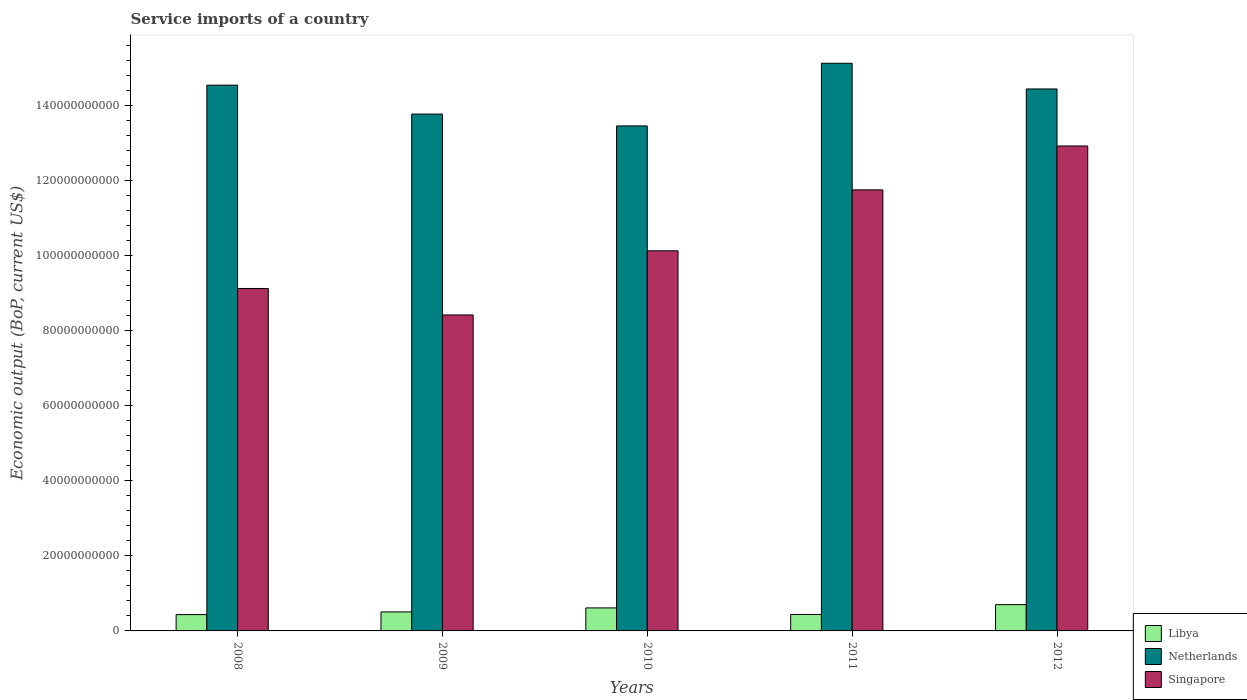Are the number of bars on each tick of the X-axis equal?
Offer a very short reply. Yes. How many bars are there on the 4th tick from the left?
Give a very brief answer. 3. How many bars are there on the 1st tick from the right?
Your answer should be very brief. 3. What is the service imports in Libya in 2010?
Ensure brevity in your answer.  6.13e+09. Across all years, what is the maximum service imports in Libya?
Ensure brevity in your answer.  7.00e+09. Across all years, what is the minimum service imports in Libya?
Ensure brevity in your answer.  4.34e+09. What is the total service imports in Libya in the graph?
Make the answer very short. 2.69e+1. What is the difference between the service imports in Singapore in 2008 and that in 2012?
Make the answer very short. -3.79e+1. What is the difference between the service imports in Netherlands in 2008 and the service imports in Libya in 2012?
Offer a terse response. 1.38e+11. What is the average service imports in Netherlands per year?
Provide a short and direct response. 1.43e+11. In the year 2010, what is the difference between the service imports in Netherlands and service imports in Libya?
Make the answer very short. 1.28e+11. In how many years, is the service imports in Netherlands greater than 48000000000 US$?
Your answer should be very brief. 5. What is the ratio of the service imports in Libya in 2008 to that in 2012?
Provide a succinct answer. 0.62. Is the service imports in Netherlands in 2011 less than that in 2012?
Give a very brief answer. No. What is the difference between the highest and the second highest service imports in Netherlands?
Your answer should be compact. 5.83e+09. What is the difference between the highest and the lowest service imports in Libya?
Your response must be concise. 2.65e+09. Is the sum of the service imports in Singapore in 2011 and 2012 greater than the maximum service imports in Netherlands across all years?
Offer a terse response. Yes. What does the 2nd bar from the left in 2012 represents?
Keep it short and to the point. Netherlands. What does the 1st bar from the right in 2008 represents?
Your answer should be compact. Singapore. Are all the bars in the graph horizontal?
Your answer should be very brief. No. How many years are there in the graph?
Your response must be concise. 5. How many legend labels are there?
Offer a terse response. 3. How are the legend labels stacked?
Provide a short and direct response. Vertical. What is the title of the graph?
Give a very brief answer. Service imports of a country. Does "Lebanon" appear as one of the legend labels in the graph?
Offer a terse response. No. What is the label or title of the X-axis?
Provide a succinct answer. Years. What is the label or title of the Y-axis?
Your answer should be very brief. Economic output (BoP, current US$). What is the Economic output (BoP, current US$) of Libya in 2008?
Offer a terse response. 4.34e+09. What is the Economic output (BoP, current US$) in Netherlands in 2008?
Offer a very short reply. 1.45e+11. What is the Economic output (BoP, current US$) of Singapore in 2008?
Offer a very short reply. 9.12e+1. What is the Economic output (BoP, current US$) in Libya in 2009?
Offer a very short reply. 5.06e+09. What is the Economic output (BoP, current US$) of Netherlands in 2009?
Provide a succinct answer. 1.38e+11. What is the Economic output (BoP, current US$) of Singapore in 2009?
Make the answer very short. 8.41e+1. What is the Economic output (BoP, current US$) of Libya in 2010?
Make the answer very short. 6.13e+09. What is the Economic output (BoP, current US$) in Netherlands in 2010?
Offer a very short reply. 1.34e+11. What is the Economic output (BoP, current US$) in Singapore in 2010?
Make the answer very short. 1.01e+11. What is the Economic output (BoP, current US$) in Libya in 2011?
Provide a short and direct response. 4.39e+09. What is the Economic output (BoP, current US$) in Netherlands in 2011?
Ensure brevity in your answer.  1.51e+11. What is the Economic output (BoP, current US$) in Singapore in 2011?
Provide a short and direct response. 1.17e+11. What is the Economic output (BoP, current US$) in Libya in 2012?
Your answer should be compact. 7.00e+09. What is the Economic output (BoP, current US$) in Netherlands in 2012?
Give a very brief answer. 1.44e+11. What is the Economic output (BoP, current US$) in Singapore in 2012?
Make the answer very short. 1.29e+11. Across all years, what is the maximum Economic output (BoP, current US$) of Libya?
Provide a short and direct response. 7.00e+09. Across all years, what is the maximum Economic output (BoP, current US$) of Netherlands?
Give a very brief answer. 1.51e+11. Across all years, what is the maximum Economic output (BoP, current US$) of Singapore?
Offer a terse response. 1.29e+11. Across all years, what is the minimum Economic output (BoP, current US$) of Libya?
Offer a terse response. 4.34e+09. Across all years, what is the minimum Economic output (BoP, current US$) of Netherlands?
Your answer should be compact. 1.34e+11. Across all years, what is the minimum Economic output (BoP, current US$) in Singapore?
Offer a very short reply. 8.41e+1. What is the total Economic output (BoP, current US$) in Libya in the graph?
Keep it short and to the point. 2.69e+1. What is the total Economic output (BoP, current US$) of Netherlands in the graph?
Make the answer very short. 7.13e+11. What is the total Economic output (BoP, current US$) in Singapore in the graph?
Provide a short and direct response. 5.23e+11. What is the difference between the Economic output (BoP, current US$) of Libya in 2008 and that in 2009?
Ensure brevity in your answer.  -7.19e+08. What is the difference between the Economic output (BoP, current US$) in Netherlands in 2008 and that in 2009?
Your response must be concise. 7.70e+09. What is the difference between the Economic output (BoP, current US$) in Singapore in 2008 and that in 2009?
Keep it short and to the point. 7.05e+09. What is the difference between the Economic output (BoP, current US$) in Libya in 2008 and that in 2010?
Keep it short and to the point. -1.78e+09. What is the difference between the Economic output (BoP, current US$) of Netherlands in 2008 and that in 2010?
Provide a short and direct response. 1.09e+1. What is the difference between the Economic output (BoP, current US$) in Singapore in 2008 and that in 2010?
Offer a very short reply. -1.00e+1. What is the difference between the Economic output (BoP, current US$) in Libya in 2008 and that in 2011?
Your response must be concise. -4.22e+07. What is the difference between the Economic output (BoP, current US$) in Netherlands in 2008 and that in 2011?
Give a very brief answer. -5.83e+09. What is the difference between the Economic output (BoP, current US$) of Singapore in 2008 and that in 2011?
Offer a very short reply. -2.63e+1. What is the difference between the Economic output (BoP, current US$) in Libya in 2008 and that in 2012?
Keep it short and to the point. -2.65e+09. What is the difference between the Economic output (BoP, current US$) of Netherlands in 2008 and that in 2012?
Give a very brief answer. 1.01e+09. What is the difference between the Economic output (BoP, current US$) in Singapore in 2008 and that in 2012?
Give a very brief answer. -3.79e+1. What is the difference between the Economic output (BoP, current US$) of Libya in 2009 and that in 2010?
Provide a succinct answer. -1.06e+09. What is the difference between the Economic output (BoP, current US$) in Netherlands in 2009 and that in 2010?
Provide a short and direct response. 3.15e+09. What is the difference between the Economic output (BoP, current US$) in Singapore in 2009 and that in 2010?
Make the answer very short. -1.71e+1. What is the difference between the Economic output (BoP, current US$) of Libya in 2009 and that in 2011?
Your response must be concise. 6.77e+08. What is the difference between the Economic output (BoP, current US$) of Netherlands in 2009 and that in 2011?
Provide a succinct answer. -1.35e+1. What is the difference between the Economic output (BoP, current US$) in Singapore in 2009 and that in 2011?
Your answer should be compact. -3.33e+1. What is the difference between the Economic output (BoP, current US$) of Libya in 2009 and that in 2012?
Offer a very short reply. -1.93e+09. What is the difference between the Economic output (BoP, current US$) in Netherlands in 2009 and that in 2012?
Your response must be concise. -6.69e+09. What is the difference between the Economic output (BoP, current US$) in Singapore in 2009 and that in 2012?
Your answer should be very brief. -4.50e+1. What is the difference between the Economic output (BoP, current US$) of Libya in 2010 and that in 2011?
Offer a terse response. 1.74e+09. What is the difference between the Economic output (BoP, current US$) in Netherlands in 2010 and that in 2011?
Your answer should be very brief. -1.67e+1. What is the difference between the Economic output (BoP, current US$) in Singapore in 2010 and that in 2011?
Provide a succinct answer. -1.62e+1. What is the difference between the Economic output (BoP, current US$) of Libya in 2010 and that in 2012?
Ensure brevity in your answer.  -8.68e+08. What is the difference between the Economic output (BoP, current US$) of Netherlands in 2010 and that in 2012?
Offer a very short reply. -9.84e+09. What is the difference between the Economic output (BoP, current US$) of Singapore in 2010 and that in 2012?
Provide a short and direct response. -2.79e+1. What is the difference between the Economic output (BoP, current US$) in Libya in 2011 and that in 2012?
Keep it short and to the point. -2.61e+09. What is the difference between the Economic output (BoP, current US$) of Netherlands in 2011 and that in 2012?
Offer a very short reply. 6.84e+09. What is the difference between the Economic output (BoP, current US$) of Singapore in 2011 and that in 2012?
Keep it short and to the point. -1.17e+1. What is the difference between the Economic output (BoP, current US$) of Libya in 2008 and the Economic output (BoP, current US$) of Netherlands in 2009?
Offer a terse response. -1.33e+11. What is the difference between the Economic output (BoP, current US$) of Libya in 2008 and the Economic output (BoP, current US$) of Singapore in 2009?
Offer a terse response. -7.98e+1. What is the difference between the Economic output (BoP, current US$) in Netherlands in 2008 and the Economic output (BoP, current US$) in Singapore in 2009?
Your answer should be very brief. 6.12e+1. What is the difference between the Economic output (BoP, current US$) of Libya in 2008 and the Economic output (BoP, current US$) of Netherlands in 2010?
Offer a very short reply. -1.30e+11. What is the difference between the Economic output (BoP, current US$) in Libya in 2008 and the Economic output (BoP, current US$) in Singapore in 2010?
Provide a short and direct response. -9.69e+1. What is the difference between the Economic output (BoP, current US$) of Netherlands in 2008 and the Economic output (BoP, current US$) of Singapore in 2010?
Provide a succinct answer. 4.41e+1. What is the difference between the Economic output (BoP, current US$) in Libya in 2008 and the Economic output (BoP, current US$) in Netherlands in 2011?
Provide a succinct answer. -1.47e+11. What is the difference between the Economic output (BoP, current US$) in Libya in 2008 and the Economic output (BoP, current US$) in Singapore in 2011?
Your answer should be compact. -1.13e+11. What is the difference between the Economic output (BoP, current US$) of Netherlands in 2008 and the Economic output (BoP, current US$) of Singapore in 2011?
Offer a very short reply. 2.79e+1. What is the difference between the Economic output (BoP, current US$) of Libya in 2008 and the Economic output (BoP, current US$) of Netherlands in 2012?
Give a very brief answer. -1.40e+11. What is the difference between the Economic output (BoP, current US$) of Libya in 2008 and the Economic output (BoP, current US$) of Singapore in 2012?
Keep it short and to the point. -1.25e+11. What is the difference between the Economic output (BoP, current US$) of Netherlands in 2008 and the Economic output (BoP, current US$) of Singapore in 2012?
Keep it short and to the point. 1.62e+1. What is the difference between the Economic output (BoP, current US$) in Libya in 2009 and the Economic output (BoP, current US$) in Netherlands in 2010?
Ensure brevity in your answer.  -1.29e+11. What is the difference between the Economic output (BoP, current US$) of Libya in 2009 and the Economic output (BoP, current US$) of Singapore in 2010?
Make the answer very short. -9.61e+1. What is the difference between the Economic output (BoP, current US$) in Netherlands in 2009 and the Economic output (BoP, current US$) in Singapore in 2010?
Offer a very short reply. 3.64e+1. What is the difference between the Economic output (BoP, current US$) in Libya in 2009 and the Economic output (BoP, current US$) in Netherlands in 2011?
Your response must be concise. -1.46e+11. What is the difference between the Economic output (BoP, current US$) of Libya in 2009 and the Economic output (BoP, current US$) of Singapore in 2011?
Your answer should be compact. -1.12e+11. What is the difference between the Economic output (BoP, current US$) of Netherlands in 2009 and the Economic output (BoP, current US$) of Singapore in 2011?
Ensure brevity in your answer.  2.02e+1. What is the difference between the Economic output (BoP, current US$) in Libya in 2009 and the Economic output (BoP, current US$) in Netherlands in 2012?
Your answer should be compact. -1.39e+11. What is the difference between the Economic output (BoP, current US$) in Libya in 2009 and the Economic output (BoP, current US$) in Singapore in 2012?
Offer a very short reply. -1.24e+11. What is the difference between the Economic output (BoP, current US$) of Netherlands in 2009 and the Economic output (BoP, current US$) of Singapore in 2012?
Provide a short and direct response. 8.49e+09. What is the difference between the Economic output (BoP, current US$) of Libya in 2010 and the Economic output (BoP, current US$) of Netherlands in 2011?
Offer a very short reply. -1.45e+11. What is the difference between the Economic output (BoP, current US$) in Libya in 2010 and the Economic output (BoP, current US$) in Singapore in 2011?
Give a very brief answer. -1.11e+11. What is the difference between the Economic output (BoP, current US$) of Netherlands in 2010 and the Economic output (BoP, current US$) of Singapore in 2011?
Give a very brief answer. 1.70e+1. What is the difference between the Economic output (BoP, current US$) in Libya in 2010 and the Economic output (BoP, current US$) in Netherlands in 2012?
Make the answer very short. -1.38e+11. What is the difference between the Economic output (BoP, current US$) in Libya in 2010 and the Economic output (BoP, current US$) in Singapore in 2012?
Keep it short and to the point. -1.23e+11. What is the difference between the Economic output (BoP, current US$) in Netherlands in 2010 and the Economic output (BoP, current US$) in Singapore in 2012?
Make the answer very short. 5.34e+09. What is the difference between the Economic output (BoP, current US$) in Libya in 2011 and the Economic output (BoP, current US$) in Netherlands in 2012?
Provide a succinct answer. -1.40e+11. What is the difference between the Economic output (BoP, current US$) in Libya in 2011 and the Economic output (BoP, current US$) in Singapore in 2012?
Your response must be concise. -1.25e+11. What is the difference between the Economic output (BoP, current US$) of Netherlands in 2011 and the Economic output (BoP, current US$) of Singapore in 2012?
Keep it short and to the point. 2.20e+1. What is the average Economic output (BoP, current US$) of Libya per year?
Make the answer very short. 5.38e+09. What is the average Economic output (BoP, current US$) of Netherlands per year?
Make the answer very short. 1.43e+11. What is the average Economic output (BoP, current US$) of Singapore per year?
Give a very brief answer. 1.05e+11. In the year 2008, what is the difference between the Economic output (BoP, current US$) of Libya and Economic output (BoP, current US$) of Netherlands?
Offer a terse response. -1.41e+11. In the year 2008, what is the difference between the Economic output (BoP, current US$) in Libya and Economic output (BoP, current US$) in Singapore?
Ensure brevity in your answer.  -8.68e+1. In the year 2008, what is the difference between the Economic output (BoP, current US$) of Netherlands and Economic output (BoP, current US$) of Singapore?
Provide a short and direct response. 5.41e+1. In the year 2009, what is the difference between the Economic output (BoP, current US$) in Libya and Economic output (BoP, current US$) in Netherlands?
Make the answer very short. -1.33e+11. In the year 2009, what is the difference between the Economic output (BoP, current US$) of Libya and Economic output (BoP, current US$) of Singapore?
Give a very brief answer. -7.91e+1. In the year 2009, what is the difference between the Economic output (BoP, current US$) of Netherlands and Economic output (BoP, current US$) of Singapore?
Provide a succinct answer. 5.35e+1. In the year 2010, what is the difference between the Economic output (BoP, current US$) in Libya and Economic output (BoP, current US$) in Netherlands?
Your response must be concise. -1.28e+11. In the year 2010, what is the difference between the Economic output (BoP, current US$) in Libya and Economic output (BoP, current US$) in Singapore?
Give a very brief answer. -9.51e+1. In the year 2010, what is the difference between the Economic output (BoP, current US$) in Netherlands and Economic output (BoP, current US$) in Singapore?
Provide a short and direct response. 3.33e+1. In the year 2011, what is the difference between the Economic output (BoP, current US$) in Libya and Economic output (BoP, current US$) in Netherlands?
Provide a succinct answer. -1.47e+11. In the year 2011, what is the difference between the Economic output (BoP, current US$) in Libya and Economic output (BoP, current US$) in Singapore?
Offer a terse response. -1.13e+11. In the year 2011, what is the difference between the Economic output (BoP, current US$) of Netherlands and Economic output (BoP, current US$) of Singapore?
Your answer should be compact. 3.37e+1. In the year 2012, what is the difference between the Economic output (BoP, current US$) in Libya and Economic output (BoP, current US$) in Netherlands?
Your answer should be compact. -1.37e+11. In the year 2012, what is the difference between the Economic output (BoP, current US$) in Libya and Economic output (BoP, current US$) in Singapore?
Offer a very short reply. -1.22e+11. In the year 2012, what is the difference between the Economic output (BoP, current US$) of Netherlands and Economic output (BoP, current US$) of Singapore?
Provide a short and direct response. 1.52e+1. What is the ratio of the Economic output (BoP, current US$) of Libya in 2008 to that in 2009?
Ensure brevity in your answer.  0.86. What is the ratio of the Economic output (BoP, current US$) of Netherlands in 2008 to that in 2009?
Provide a succinct answer. 1.06. What is the ratio of the Economic output (BoP, current US$) of Singapore in 2008 to that in 2009?
Your answer should be very brief. 1.08. What is the ratio of the Economic output (BoP, current US$) in Libya in 2008 to that in 2010?
Offer a very short reply. 0.71. What is the ratio of the Economic output (BoP, current US$) of Netherlands in 2008 to that in 2010?
Provide a short and direct response. 1.08. What is the ratio of the Economic output (BoP, current US$) in Singapore in 2008 to that in 2010?
Give a very brief answer. 0.9. What is the ratio of the Economic output (BoP, current US$) of Libya in 2008 to that in 2011?
Offer a very short reply. 0.99. What is the ratio of the Economic output (BoP, current US$) of Netherlands in 2008 to that in 2011?
Ensure brevity in your answer.  0.96. What is the ratio of the Economic output (BoP, current US$) in Singapore in 2008 to that in 2011?
Provide a short and direct response. 0.78. What is the ratio of the Economic output (BoP, current US$) in Libya in 2008 to that in 2012?
Provide a succinct answer. 0.62. What is the ratio of the Economic output (BoP, current US$) in Singapore in 2008 to that in 2012?
Your answer should be compact. 0.71. What is the ratio of the Economic output (BoP, current US$) in Libya in 2009 to that in 2010?
Offer a terse response. 0.83. What is the ratio of the Economic output (BoP, current US$) in Netherlands in 2009 to that in 2010?
Make the answer very short. 1.02. What is the ratio of the Economic output (BoP, current US$) of Singapore in 2009 to that in 2010?
Offer a very short reply. 0.83. What is the ratio of the Economic output (BoP, current US$) of Libya in 2009 to that in 2011?
Offer a terse response. 1.15. What is the ratio of the Economic output (BoP, current US$) in Netherlands in 2009 to that in 2011?
Keep it short and to the point. 0.91. What is the ratio of the Economic output (BoP, current US$) of Singapore in 2009 to that in 2011?
Offer a terse response. 0.72. What is the ratio of the Economic output (BoP, current US$) of Libya in 2009 to that in 2012?
Keep it short and to the point. 0.72. What is the ratio of the Economic output (BoP, current US$) of Netherlands in 2009 to that in 2012?
Make the answer very short. 0.95. What is the ratio of the Economic output (BoP, current US$) of Singapore in 2009 to that in 2012?
Provide a short and direct response. 0.65. What is the ratio of the Economic output (BoP, current US$) in Libya in 2010 to that in 2011?
Your answer should be compact. 1.4. What is the ratio of the Economic output (BoP, current US$) of Netherlands in 2010 to that in 2011?
Keep it short and to the point. 0.89. What is the ratio of the Economic output (BoP, current US$) in Singapore in 2010 to that in 2011?
Ensure brevity in your answer.  0.86. What is the ratio of the Economic output (BoP, current US$) of Libya in 2010 to that in 2012?
Offer a terse response. 0.88. What is the ratio of the Economic output (BoP, current US$) of Netherlands in 2010 to that in 2012?
Make the answer very short. 0.93. What is the ratio of the Economic output (BoP, current US$) of Singapore in 2010 to that in 2012?
Ensure brevity in your answer.  0.78. What is the ratio of the Economic output (BoP, current US$) of Libya in 2011 to that in 2012?
Keep it short and to the point. 0.63. What is the ratio of the Economic output (BoP, current US$) in Netherlands in 2011 to that in 2012?
Give a very brief answer. 1.05. What is the ratio of the Economic output (BoP, current US$) in Singapore in 2011 to that in 2012?
Provide a succinct answer. 0.91. What is the difference between the highest and the second highest Economic output (BoP, current US$) of Libya?
Your answer should be very brief. 8.68e+08. What is the difference between the highest and the second highest Economic output (BoP, current US$) in Netherlands?
Your answer should be very brief. 5.83e+09. What is the difference between the highest and the second highest Economic output (BoP, current US$) in Singapore?
Provide a short and direct response. 1.17e+1. What is the difference between the highest and the lowest Economic output (BoP, current US$) of Libya?
Give a very brief answer. 2.65e+09. What is the difference between the highest and the lowest Economic output (BoP, current US$) in Netherlands?
Offer a terse response. 1.67e+1. What is the difference between the highest and the lowest Economic output (BoP, current US$) of Singapore?
Your answer should be compact. 4.50e+1. 